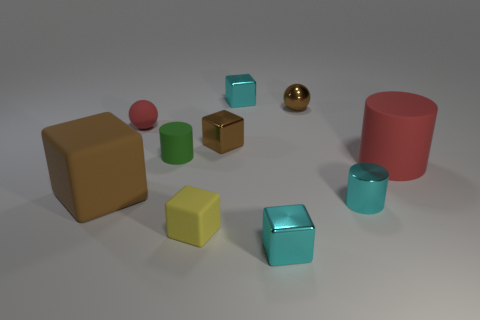Can you describe the material finishes on the objects? Certainly, the objects exhibit a variety of material finishes. Some objects have a matte texture, while others are shiny, like the golden sphere, which has a reflective surface. These finishes give each object a distinct visual quality.  Can you identify the reflective surface in the image? The golden sphere has a reflective surface that stands out among the matte finishes of the other objects. Its mirror-like quality differentiates it visually from the other shapes present. 